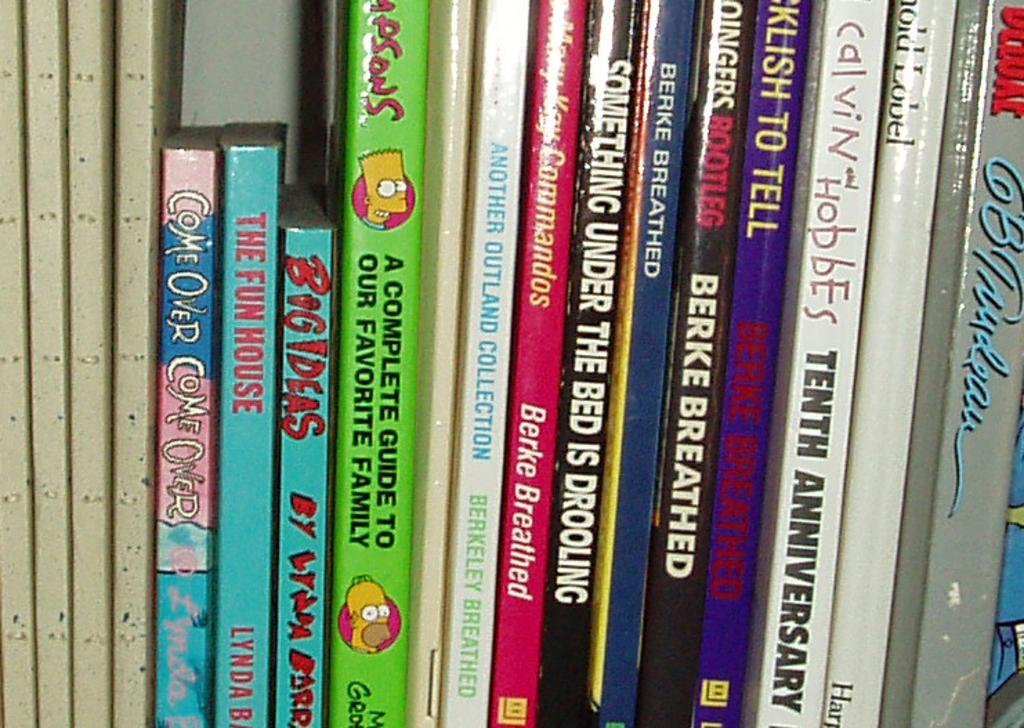<image>
Render a clear and concise summary of the photo. A book called  Big Ideas sits next to a book about the Simpsons on a shelf 